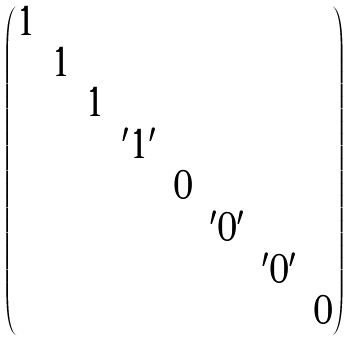Convert formula to latex. <formula><loc_0><loc_0><loc_500><loc_500>\begin{pmatrix} 1 & & & & & & & \\ & 1 & & & & & & \\ & & 1 & & & & & \\ & & & ^ { \prime } 1 ^ { \prime } & & & & \\ & & & & 0 & & & \\ & & & & & ^ { \prime } 0 ^ { \prime } & & \\ & & & & & & ^ { \prime } 0 ^ { \prime } & \\ & & & & & & & 0 \end{pmatrix}</formula> 